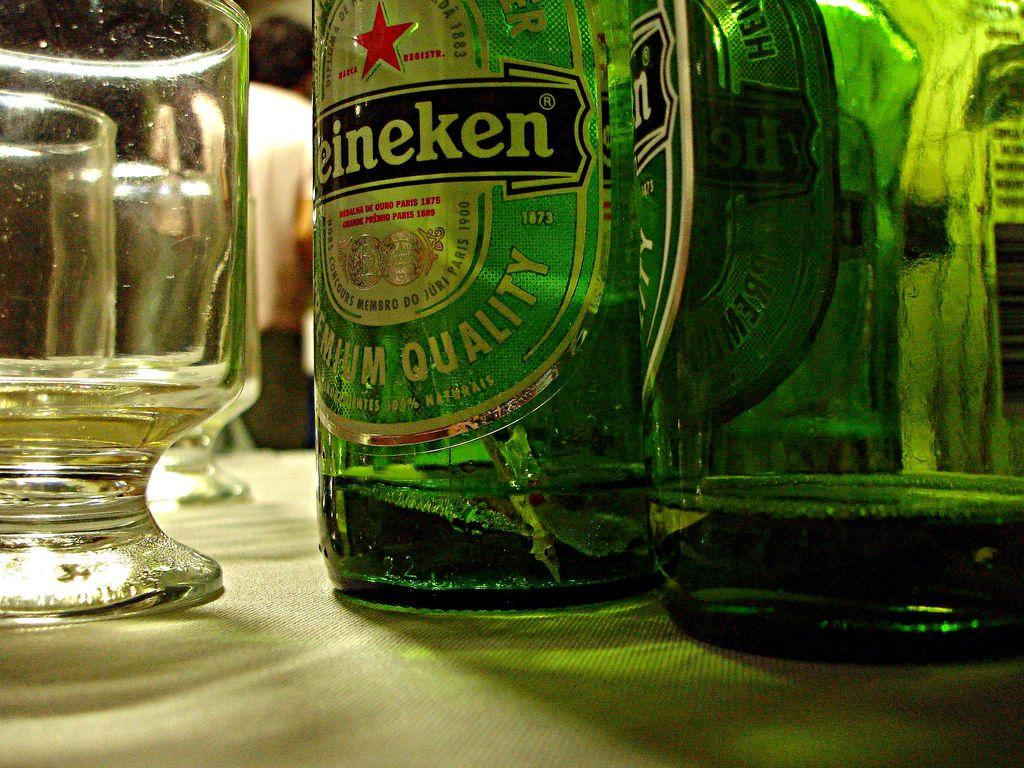<image>
Summarize the visual content of the image. Two bottles with Heineken labels are next to a glass. 